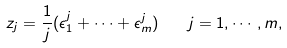<formula> <loc_0><loc_0><loc_500><loc_500>z _ { j } = \frac { 1 } { j } ( \epsilon _ { 1 } ^ { j } + \cdots + \epsilon _ { m } ^ { j } ) \quad j = 1 , \cdots , m ,</formula> 